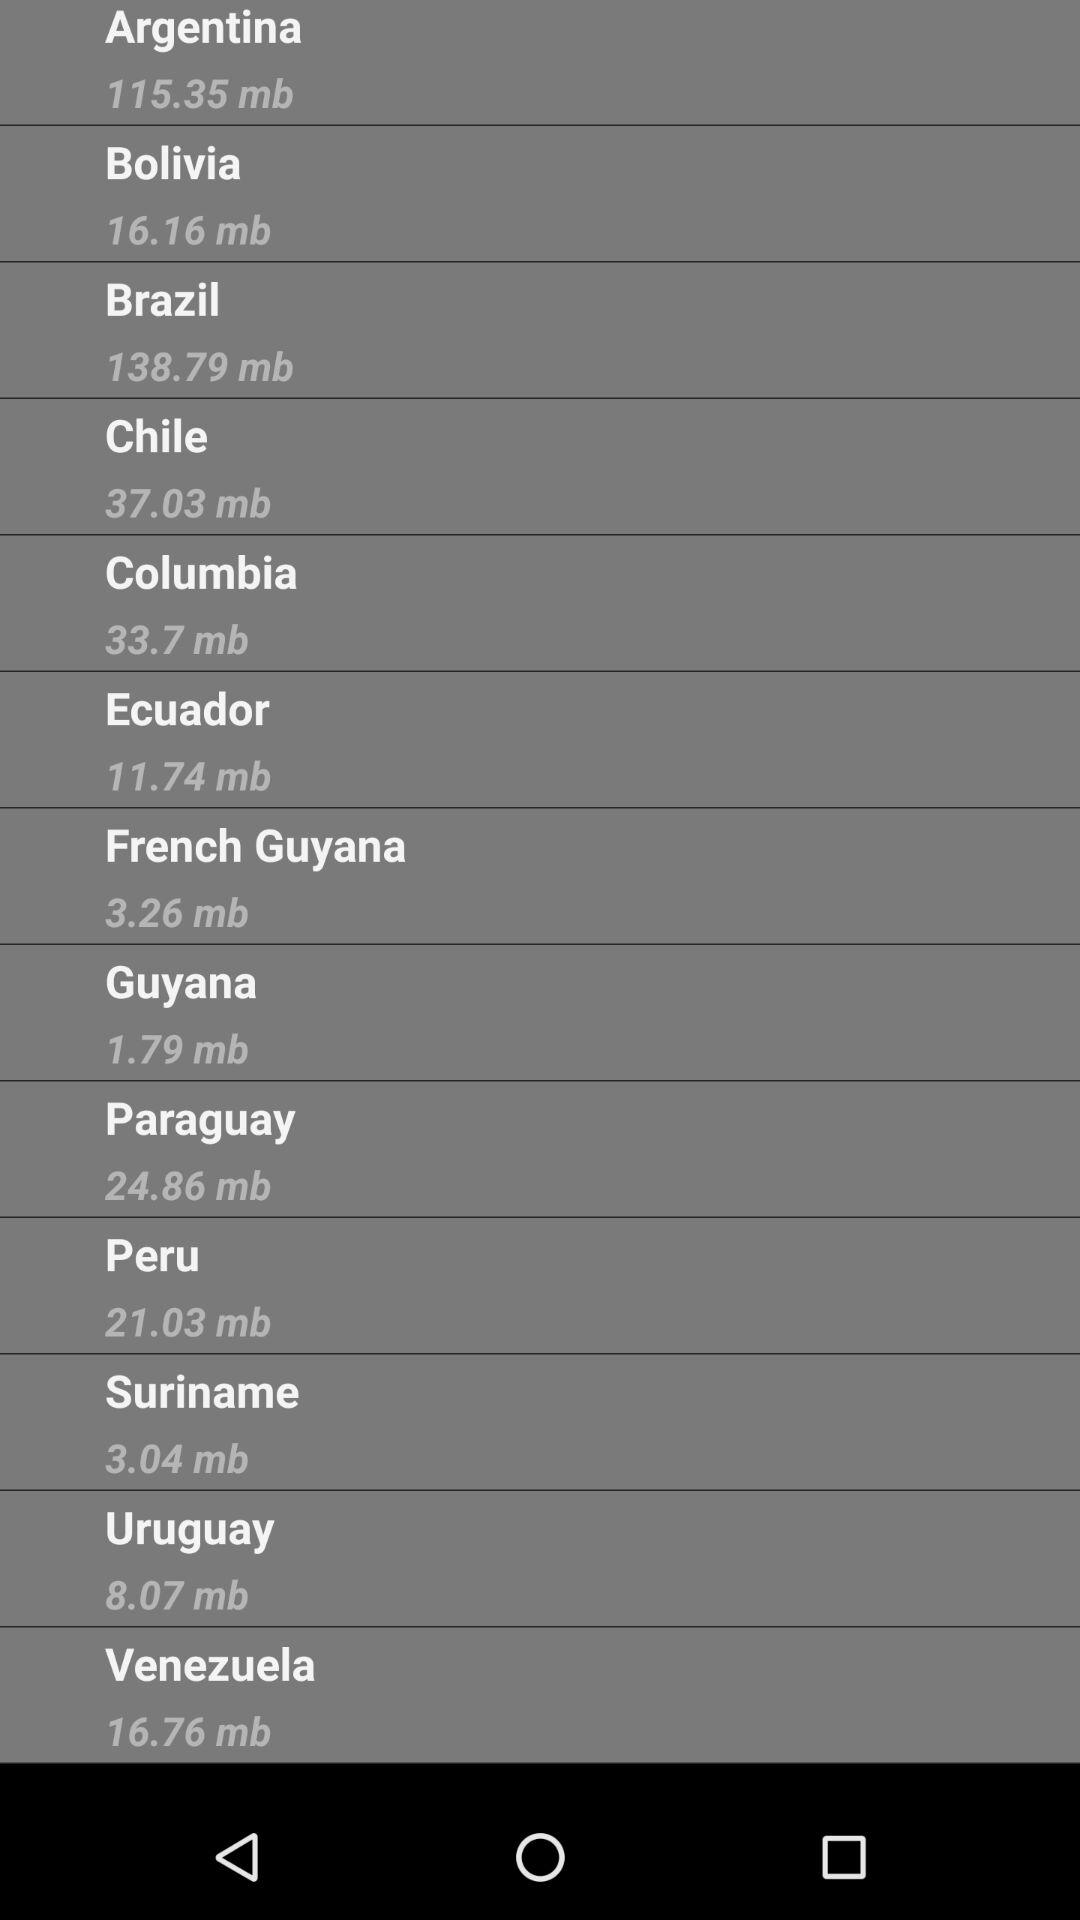What is the size of Argentina in mb? The size is 115.35 mb. 